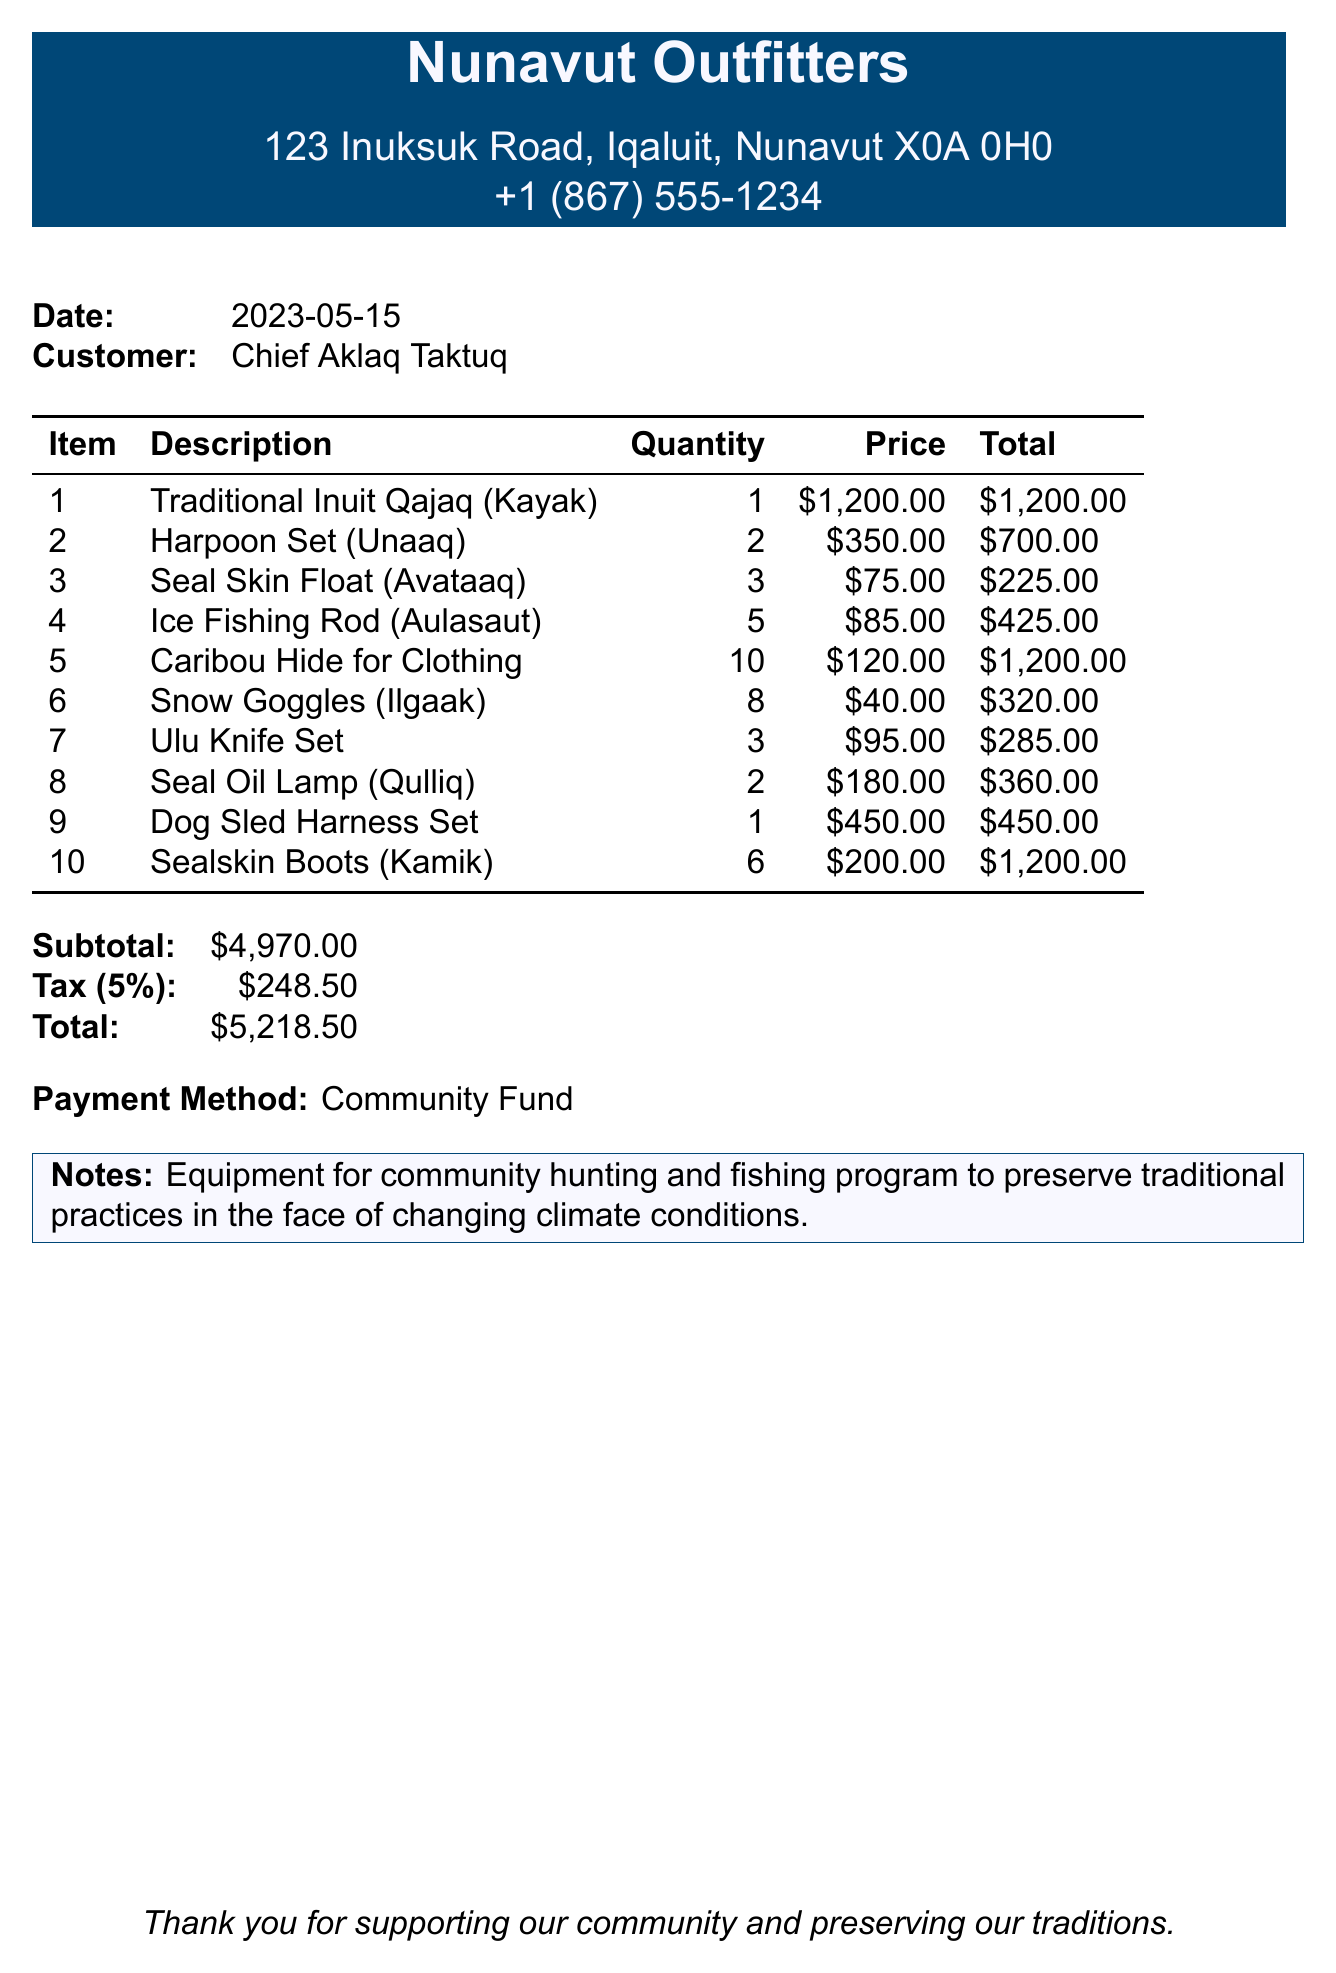What is the store name? The store name is the first piece of information presented in the document.
Answer: Nunavut Outfitters What is the purchase date? The purchase date is clearly mentioned in the header section of the receipt.
Answer: 2023-05-15 Who is the customer? The customer's name is indicated next to the "Customer" heading in the document.
Answer: Chief Aklaq Taktuq What is the total amount spent? The total amount is located at the bottom of the receipt, summarizing the costs.
Answer: $5,218.50 How many Ice Fishing Rods were purchased? The quantity of Ice Fishing Rods can be found in the itemized list of supplies.
Answer: 5 What is the price of one Ulu Knife Set? The price of one Ulu Knife Set is listed in the receipt under the item details.
Answer: $95.00 How many items were purchased in total? To find the total number of items, one must sum the quantities of each item listed.
Answer: 36 What is the payment method? The payment method is stated near the end of the document under "Payment Method."
Answer: Community Fund What is noted about the equipment purchased? The notes section provides context about the purpose of the equipment.
Answer: Equipment for community hunting and fishing program to preserve traditional practices in the face of changing climate conditions 